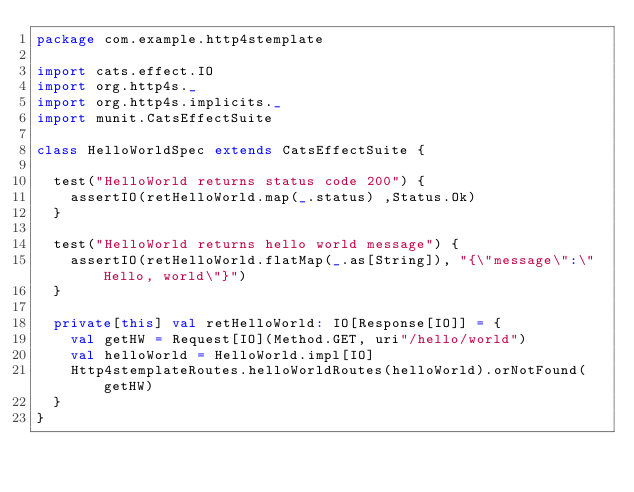Convert code to text. <code><loc_0><loc_0><loc_500><loc_500><_Scala_>package com.example.http4stemplate

import cats.effect.IO
import org.http4s._
import org.http4s.implicits._
import munit.CatsEffectSuite

class HelloWorldSpec extends CatsEffectSuite {

  test("HelloWorld returns status code 200") {
    assertIO(retHelloWorld.map(_.status) ,Status.Ok)
  }

  test("HelloWorld returns hello world message") {
    assertIO(retHelloWorld.flatMap(_.as[String]), "{\"message\":\"Hello, world\"}")
  }

  private[this] val retHelloWorld: IO[Response[IO]] = {
    val getHW = Request[IO](Method.GET, uri"/hello/world")
    val helloWorld = HelloWorld.impl[IO]
    Http4stemplateRoutes.helloWorldRoutes(helloWorld).orNotFound(getHW)
  }
}</code> 